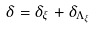<formula> <loc_0><loc_0><loc_500><loc_500>\delta = \delta _ { \xi } + \delta _ { \Lambda _ { \xi } }</formula> 